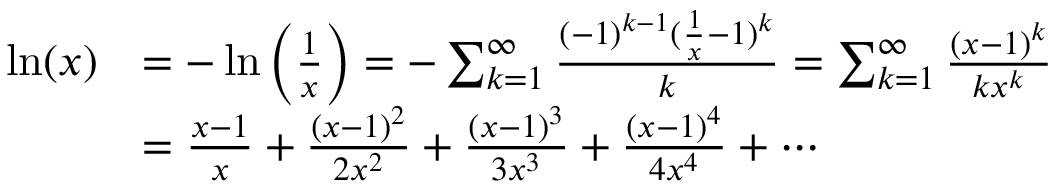Convert formula to latex. <formula><loc_0><loc_0><loc_500><loc_500>{ \begin{array} { r l } { \ln ( x ) } & { = - \ln \left ( { \frac { 1 } { x } } \right ) = - \sum _ { k = 1 } ^ { \infty } { \frac { ( - 1 ) ^ { k - 1 } ( { \frac { 1 } { x } } - 1 ) ^ { k } } { k } } = \sum _ { k = 1 } ^ { \infty } { \frac { ( x - 1 ) ^ { k } } { k x ^ { k } } } } \\ & { = { \frac { x - 1 } { x } } + { \frac { ( x - 1 ) ^ { 2 } } { 2 x ^ { 2 } } } + { \frac { ( x - 1 ) ^ { 3 } } { 3 x ^ { 3 } } } + { \frac { ( x - 1 ) ^ { 4 } } { 4 x ^ { 4 } } } + \cdots } \end{array} }</formula> 